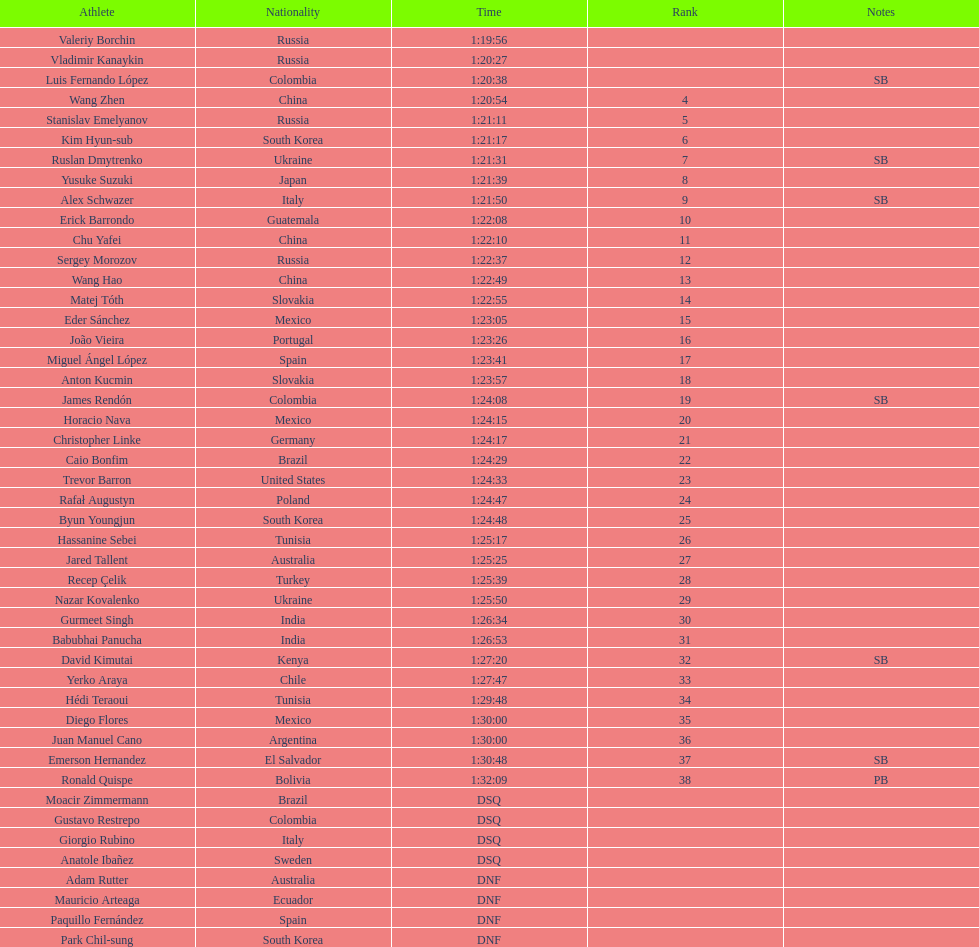How many russians finished at least 3rd in the 20km walk? 2. 